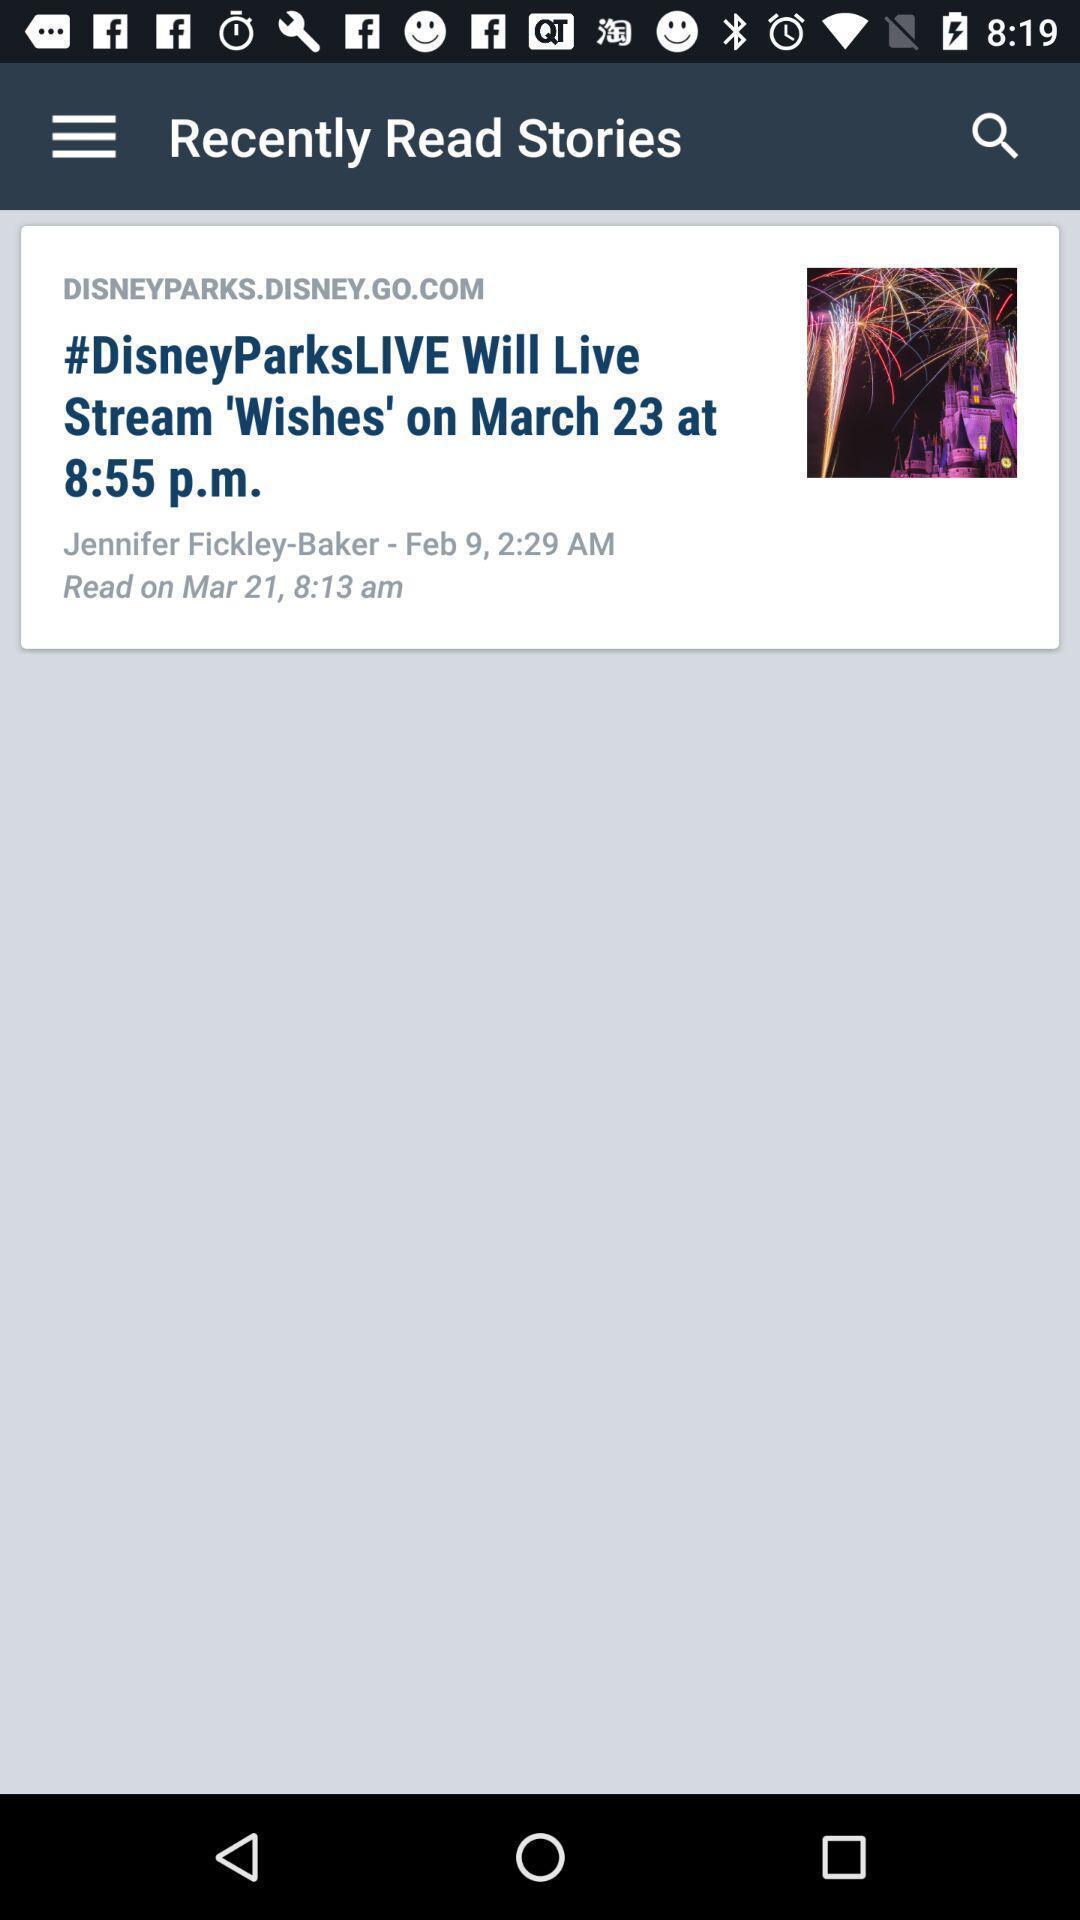Give me a narrative description of this picture. Page displaying the story. 